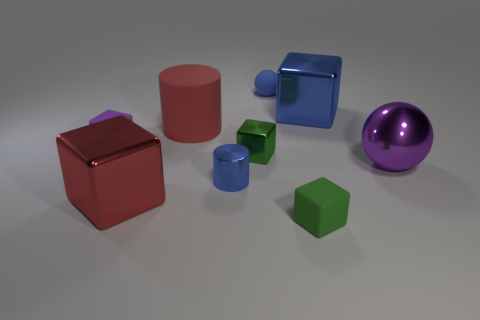Subtract all big red metal cubes. How many cubes are left? 4 Subtract all red spheres. How many green blocks are left? 2 Subtract all red cylinders. How many cylinders are left? 1 Add 1 large cyan matte cubes. How many objects exist? 10 Subtract all blocks. How many objects are left? 4 Subtract 4 cubes. How many cubes are left? 1 Add 2 large red cylinders. How many large red cylinders exist? 3 Subtract 0 brown balls. How many objects are left? 9 Subtract all blue balls. Subtract all yellow cubes. How many balls are left? 1 Subtract all blue spheres. Subtract all large purple shiny spheres. How many objects are left? 7 